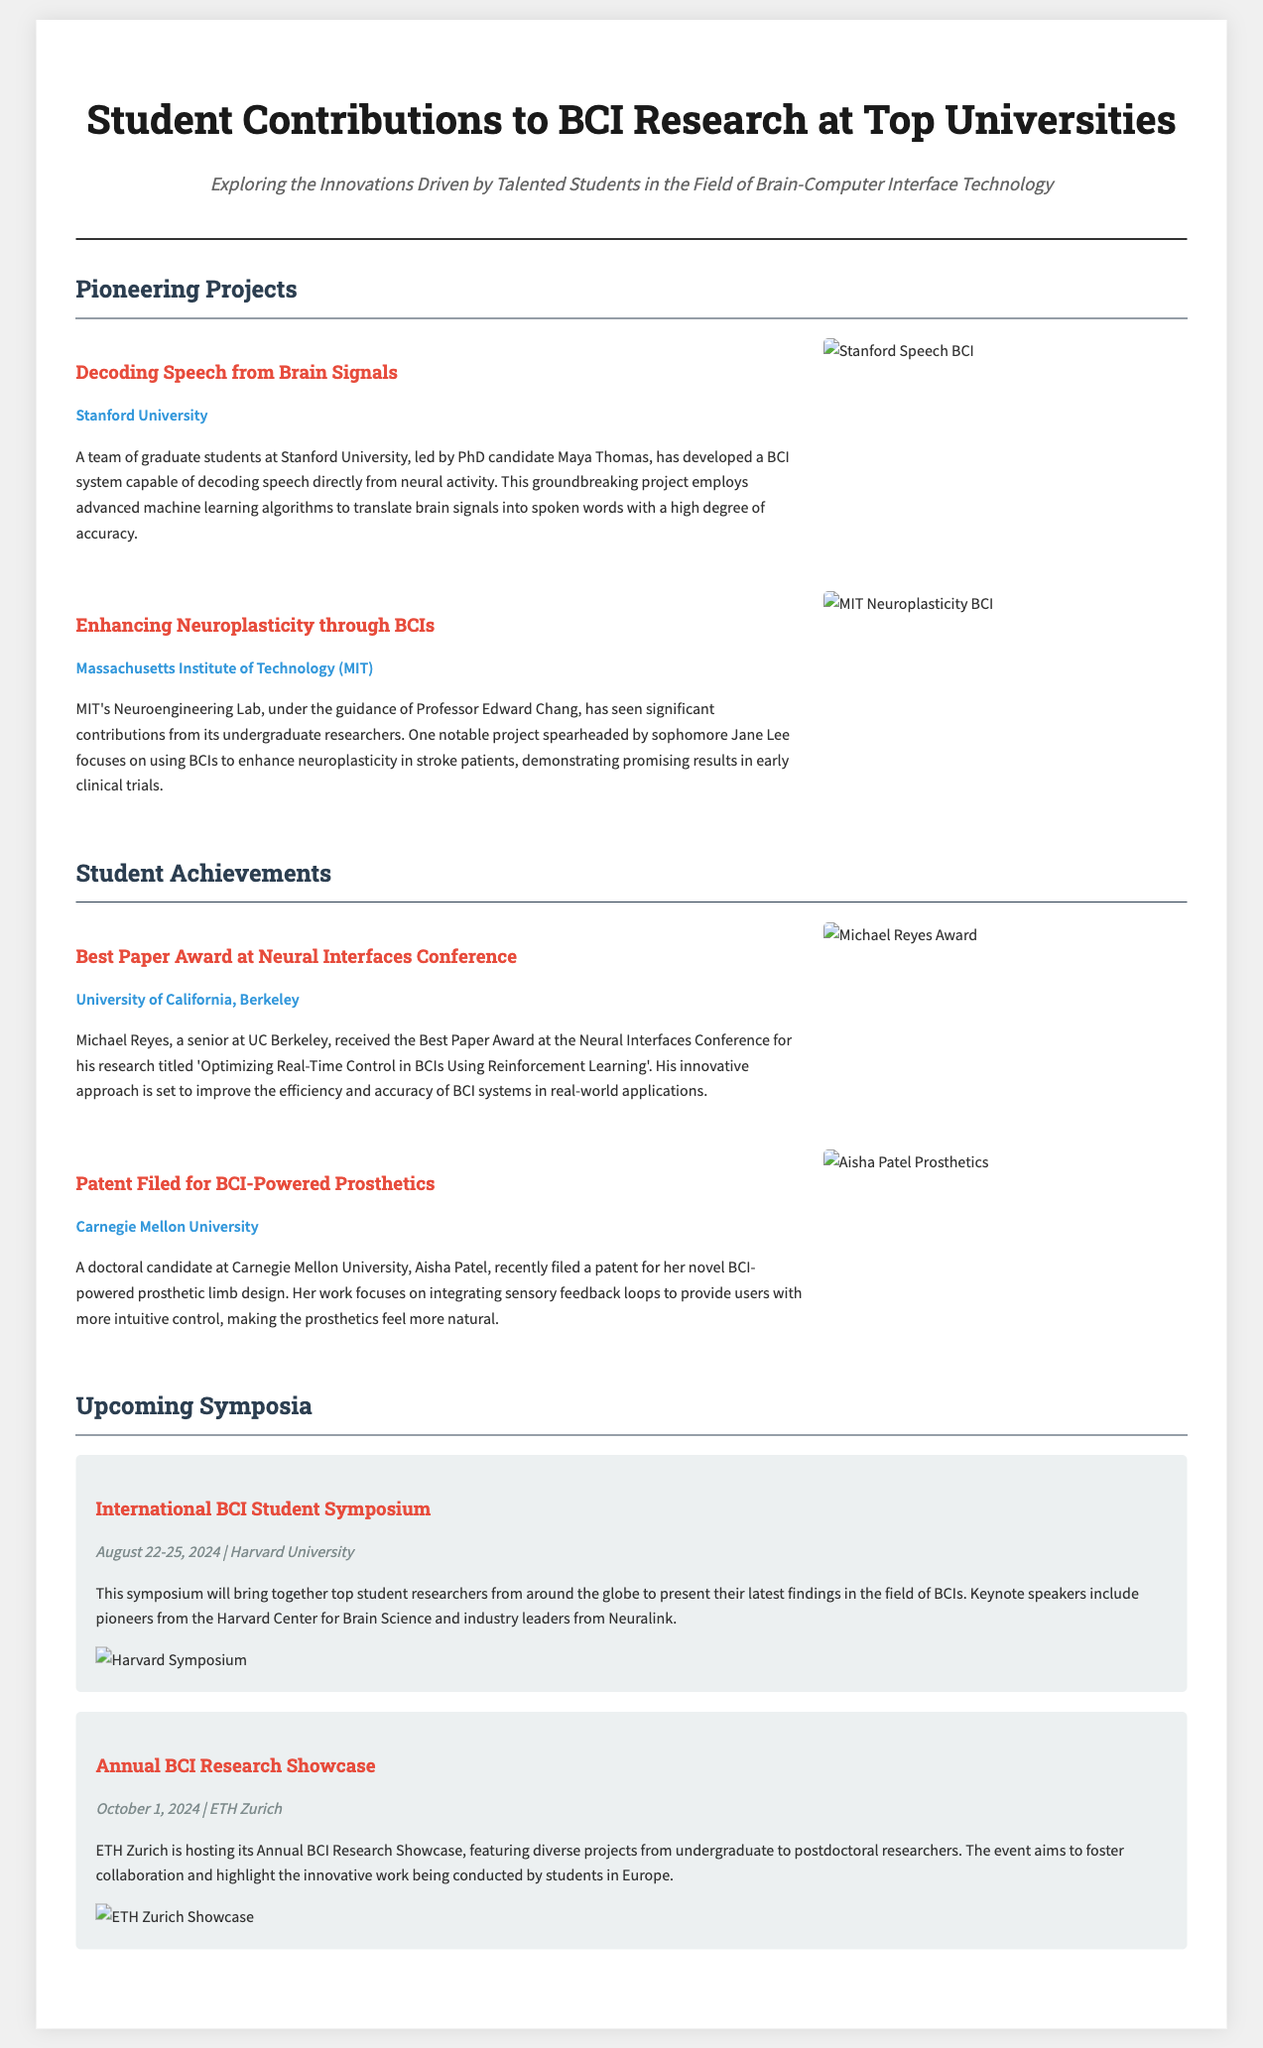What is the title of the project led by Maya Thomas? The title of the project is stated in the article section about Stanford University, which is "Decoding Speech from Brain Signals."
Answer: Decoding Speech from Brain Signals Who is the recipient of the Best Paper Award at the Neural Interfaces Conference? The recipient's name is mentioned in the article under the achievements section for UC Berkeley, which is Michael Reyes.
Answer: Michael Reyes When is the International BCI Student Symposium scheduled? The date of the symposium is detailed in the upcoming symposia section, which is August 22-25, 2024.
Answer: August 22-25, 2024 Which university is conducting a project on enhancing neuroplasticity? The university mentioned in the article focusing on neuroplasticity through BCIs is MIT (Massachusetts Institute of Technology).
Answer: Massachusetts Institute of Technology What innovative feature is included in Aisha Patel's prosthetic limb design? The document explains that Aisha Patel's design focuses on integrating sensory feedback loops, which is an innovative feature.
Answer: Sensory feedback loops What university hosted the Annual BCI Research Showcase? The article states that the Annual BCI Research Showcase is being hosted by ETH Zurich.
Answer: ETH Zurich What is the focus of Jane Lee's project at MIT? The focus of Jane Lee's project, as outlined in the MIT article, is on using BCIs to enhance neuroplasticity in stroke patients.
Answer: Enhance neuroplasticity in stroke patients What color is used for the title in the newspaper layout? The color for the title is specified within the styles of the document, which is a dark shade (#1a1a1a).
Answer: #1a1a1a How many articles are listed in the "Pioneering Projects" section? The number of articles in the "Pioneering Projects" section can be counted and is indicated as two in the document.
Answer: 2 